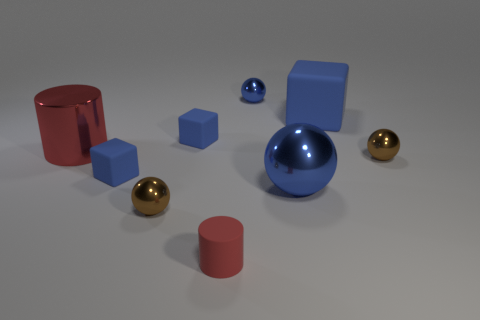Add 1 big red metal things. How many objects exist? 10 Subtract all spheres. How many objects are left? 5 Subtract 0 cyan blocks. How many objects are left? 9 Subtract all cubes. Subtract all blue cubes. How many objects are left? 3 Add 1 big red cylinders. How many big red cylinders are left? 2 Add 1 small blue shiny objects. How many small blue shiny objects exist? 2 